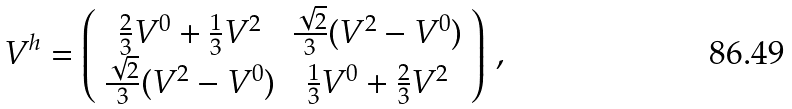<formula> <loc_0><loc_0><loc_500><loc_500>V ^ { h } = \left ( \begin{array} { c c } \frac { 2 } { 3 } V ^ { 0 } + \frac { 1 } { 3 } V ^ { 2 } & \frac { \sqrt { 2 } } { 3 } ( V ^ { 2 } - V ^ { 0 } ) \\ \frac { \sqrt { 2 } } { 3 } ( V ^ { 2 } - V ^ { 0 } ) & \frac { 1 } { 3 } V ^ { 0 } + \frac { 2 } { 3 } V ^ { 2 } \end{array} \right ) \, ,</formula> 